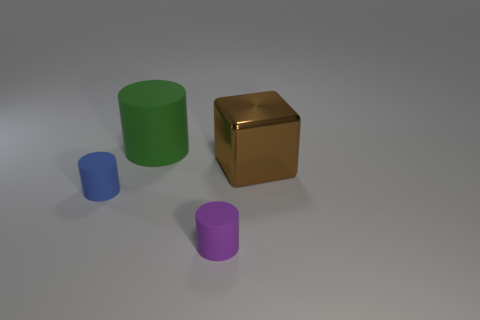Add 4 tiny cyan rubber spheres. How many objects exist? 8 Subtract all cubes. How many objects are left? 3 Add 4 cubes. How many cubes are left? 5 Add 4 small blue balls. How many small blue balls exist? 4 Subtract 0 red cylinders. How many objects are left? 4 Subtract all small red cubes. Subtract all green matte things. How many objects are left? 3 